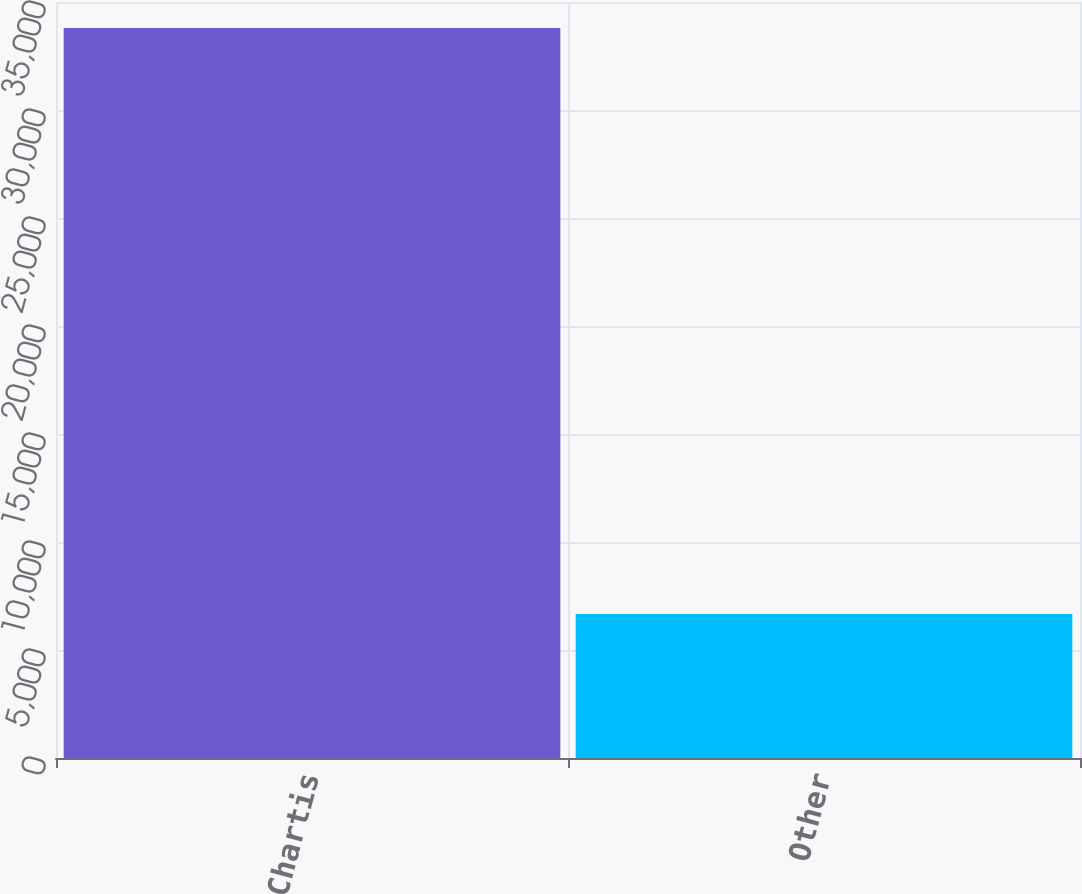Convert chart to OTSL. <chart><loc_0><loc_0><loc_500><loc_500><bar_chart><fcel>Chartis<fcel>Other<nl><fcel>33793<fcel>6670<nl></chart> 